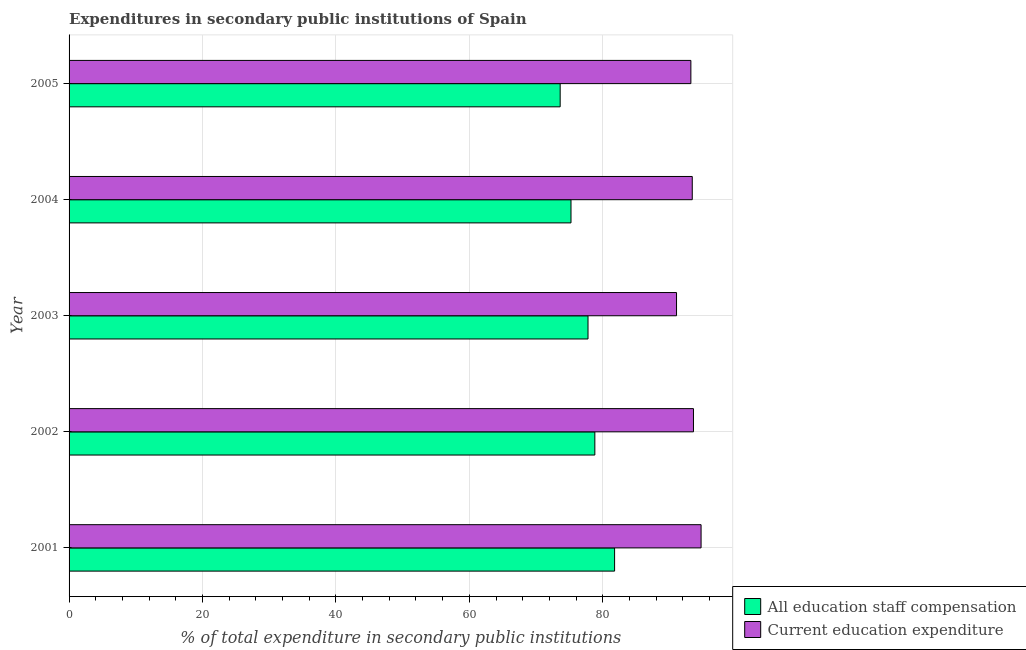Are the number of bars on each tick of the Y-axis equal?
Ensure brevity in your answer.  Yes. How many bars are there on the 3rd tick from the bottom?
Make the answer very short. 2. What is the expenditure in staff compensation in 2001?
Provide a succinct answer. 81.78. Across all years, what is the maximum expenditure in education?
Your answer should be compact. 94.74. Across all years, what is the minimum expenditure in education?
Provide a short and direct response. 91.06. In which year was the expenditure in staff compensation minimum?
Provide a short and direct response. 2005. What is the total expenditure in education in the graph?
Give a very brief answer. 466.05. What is the difference between the expenditure in staff compensation in 2001 and that in 2004?
Give a very brief answer. 6.53. What is the difference between the expenditure in education in 2005 and the expenditure in staff compensation in 2003?
Give a very brief answer. 15.42. What is the average expenditure in staff compensation per year?
Offer a very short reply. 77.45. In the year 2001, what is the difference between the expenditure in staff compensation and expenditure in education?
Your response must be concise. -12.97. In how many years, is the expenditure in staff compensation greater than 56 %?
Ensure brevity in your answer.  5. What is the ratio of the expenditure in staff compensation in 2001 to that in 2002?
Keep it short and to the point. 1.04. Is the difference between the expenditure in education in 2001 and 2005 greater than the difference between the expenditure in staff compensation in 2001 and 2005?
Provide a short and direct response. No. What is the difference between the highest and the second highest expenditure in education?
Offer a very short reply. 1.14. What is the difference between the highest and the lowest expenditure in education?
Your answer should be very brief. 3.68. Is the sum of the expenditure in education in 2002 and 2004 greater than the maximum expenditure in staff compensation across all years?
Keep it short and to the point. Yes. What does the 2nd bar from the top in 2001 represents?
Offer a very short reply. All education staff compensation. What does the 2nd bar from the bottom in 2002 represents?
Give a very brief answer. Current education expenditure. How many bars are there?
Offer a terse response. 10. Are all the bars in the graph horizontal?
Provide a succinct answer. Yes. How many years are there in the graph?
Ensure brevity in your answer.  5. Does the graph contain any zero values?
Offer a terse response. No. How many legend labels are there?
Ensure brevity in your answer.  2. How are the legend labels stacked?
Your answer should be very brief. Vertical. What is the title of the graph?
Your answer should be compact. Expenditures in secondary public institutions of Spain. What is the label or title of the X-axis?
Provide a short and direct response. % of total expenditure in secondary public institutions. What is the % of total expenditure in secondary public institutions in All education staff compensation in 2001?
Your answer should be compact. 81.78. What is the % of total expenditure in secondary public institutions in Current education expenditure in 2001?
Keep it short and to the point. 94.74. What is the % of total expenditure in secondary public institutions of All education staff compensation in 2002?
Offer a very short reply. 78.82. What is the % of total expenditure in secondary public institutions of Current education expenditure in 2002?
Your answer should be compact. 93.6. What is the % of total expenditure in secondary public institutions in All education staff compensation in 2003?
Keep it short and to the point. 77.79. What is the % of total expenditure in secondary public institutions in Current education expenditure in 2003?
Keep it short and to the point. 91.06. What is the % of total expenditure in secondary public institutions of All education staff compensation in 2004?
Offer a terse response. 75.24. What is the % of total expenditure in secondary public institutions in Current education expenditure in 2004?
Your answer should be compact. 93.42. What is the % of total expenditure in secondary public institutions of All education staff compensation in 2005?
Your response must be concise. 73.62. What is the % of total expenditure in secondary public institutions of Current education expenditure in 2005?
Offer a very short reply. 93.21. Across all years, what is the maximum % of total expenditure in secondary public institutions in All education staff compensation?
Your answer should be very brief. 81.78. Across all years, what is the maximum % of total expenditure in secondary public institutions in Current education expenditure?
Your answer should be compact. 94.74. Across all years, what is the minimum % of total expenditure in secondary public institutions of All education staff compensation?
Ensure brevity in your answer.  73.62. Across all years, what is the minimum % of total expenditure in secondary public institutions in Current education expenditure?
Offer a very short reply. 91.06. What is the total % of total expenditure in secondary public institutions in All education staff compensation in the graph?
Ensure brevity in your answer.  387.26. What is the total % of total expenditure in secondary public institutions in Current education expenditure in the graph?
Ensure brevity in your answer.  466.05. What is the difference between the % of total expenditure in secondary public institutions in All education staff compensation in 2001 and that in 2002?
Give a very brief answer. 2.96. What is the difference between the % of total expenditure in secondary public institutions in Current education expenditure in 2001 and that in 2002?
Give a very brief answer. 1.14. What is the difference between the % of total expenditure in secondary public institutions of All education staff compensation in 2001 and that in 2003?
Your answer should be compact. 3.98. What is the difference between the % of total expenditure in secondary public institutions of Current education expenditure in 2001 and that in 2003?
Provide a short and direct response. 3.68. What is the difference between the % of total expenditure in secondary public institutions of All education staff compensation in 2001 and that in 2004?
Provide a short and direct response. 6.53. What is the difference between the % of total expenditure in secondary public institutions of Current education expenditure in 2001 and that in 2004?
Provide a short and direct response. 1.32. What is the difference between the % of total expenditure in secondary public institutions in All education staff compensation in 2001 and that in 2005?
Give a very brief answer. 8.16. What is the difference between the % of total expenditure in secondary public institutions in Current education expenditure in 2001 and that in 2005?
Keep it short and to the point. 1.53. What is the difference between the % of total expenditure in secondary public institutions of All education staff compensation in 2002 and that in 2003?
Your answer should be compact. 1.02. What is the difference between the % of total expenditure in secondary public institutions of Current education expenditure in 2002 and that in 2003?
Offer a terse response. 2.54. What is the difference between the % of total expenditure in secondary public institutions of All education staff compensation in 2002 and that in 2004?
Offer a terse response. 3.57. What is the difference between the % of total expenditure in secondary public institutions of Current education expenditure in 2002 and that in 2004?
Ensure brevity in your answer.  0.18. What is the difference between the % of total expenditure in secondary public institutions in All education staff compensation in 2002 and that in 2005?
Ensure brevity in your answer.  5.2. What is the difference between the % of total expenditure in secondary public institutions of Current education expenditure in 2002 and that in 2005?
Provide a short and direct response. 0.39. What is the difference between the % of total expenditure in secondary public institutions of All education staff compensation in 2003 and that in 2004?
Offer a very short reply. 2.55. What is the difference between the % of total expenditure in secondary public institutions of Current education expenditure in 2003 and that in 2004?
Your answer should be very brief. -2.36. What is the difference between the % of total expenditure in secondary public institutions of All education staff compensation in 2003 and that in 2005?
Provide a short and direct response. 4.17. What is the difference between the % of total expenditure in secondary public institutions in Current education expenditure in 2003 and that in 2005?
Your answer should be very brief. -2.15. What is the difference between the % of total expenditure in secondary public institutions in All education staff compensation in 2004 and that in 2005?
Provide a short and direct response. 1.62. What is the difference between the % of total expenditure in secondary public institutions of Current education expenditure in 2004 and that in 2005?
Give a very brief answer. 0.21. What is the difference between the % of total expenditure in secondary public institutions in All education staff compensation in 2001 and the % of total expenditure in secondary public institutions in Current education expenditure in 2002?
Offer a terse response. -11.83. What is the difference between the % of total expenditure in secondary public institutions in All education staff compensation in 2001 and the % of total expenditure in secondary public institutions in Current education expenditure in 2003?
Your response must be concise. -9.29. What is the difference between the % of total expenditure in secondary public institutions in All education staff compensation in 2001 and the % of total expenditure in secondary public institutions in Current education expenditure in 2004?
Keep it short and to the point. -11.64. What is the difference between the % of total expenditure in secondary public institutions in All education staff compensation in 2001 and the % of total expenditure in secondary public institutions in Current education expenditure in 2005?
Your answer should be very brief. -11.44. What is the difference between the % of total expenditure in secondary public institutions in All education staff compensation in 2002 and the % of total expenditure in secondary public institutions in Current education expenditure in 2003?
Your answer should be compact. -12.25. What is the difference between the % of total expenditure in secondary public institutions of All education staff compensation in 2002 and the % of total expenditure in secondary public institutions of Current education expenditure in 2004?
Offer a very short reply. -14.6. What is the difference between the % of total expenditure in secondary public institutions in All education staff compensation in 2002 and the % of total expenditure in secondary public institutions in Current education expenditure in 2005?
Keep it short and to the point. -14.4. What is the difference between the % of total expenditure in secondary public institutions of All education staff compensation in 2003 and the % of total expenditure in secondary public institutions of Current education expenditure in 2004?
Give a very brief answer. -15.63. What is the difference between the % of total expenditure in secondary public institutions in All education staff compensation in 2003 and the % of total expenditure in secondary public institutions in Current education expenditure in 2005?
Keep it short and to the point. -15.42. What is the difference between the % of total expenditure in secondary public institutions of All education staff compensation in 2004 and the % of total expenditure in secondary public institutions of Current education expenditure in 2005?
Make the answer very short. -17.97. What is the average % of total expenditure in secondary public institutions in All education staff compensation per year?
Offer a terse response. 77.45. What is the average % of total expenditure in secondary public institutions of Current education expenditure per year?
Make the answer very short. 93.21. In the year 2001, what is the difference between the % of total expenditure in secondary public institutions in All education staff compensation and % of total expenditure in secondary public institutions in Current education expenditure?
Provide a short and direct response. -12.97. In the year 2002, what is the difference between the % of total expenditure in secondary public institutions in All education staff compensation and % of total expenditure in secondary public institutions in Current education expenditure?
Keep it short and to the point. -14.79. In the year 2003, what is the difference between the % of total expenditure in secondary public institutions of All education staff compensation and % of total expenditure in secondary public institutions of Current education expenditure?
Provide a succinct answer. -13.27. In the year 2004, what is the difference between the % of total expenditure in secondary public institutions of All education staff compensation and % of total expenditure in secondary public institutions of Current education expenditure?
Your response must be concise. -18.18. In the year 2005, what is the difference between the % of total expenditure in secondary public institutions in All education staff compensation and % of total expenditure in secondary public institutions in Current education expenditure?
Ensure brevity in your answer.  -19.59. What is the ratio of the % of total expenditure in secondary public institutions of All education staff compensation in 2001 to that in 2002?
Give a very brief answer. 1.04. What is the ratio of the % of total expenditure in secondary public institutions of Current education expenditure in 2001 to that in 2002?
Ensure brevity in your answer.  1.01. What is the ratio of the % of total expenditure in secondary public institutions in All education staff compensation in 2001 to that in 2003?
Your answer should be compact. 1.05. What is the ratio of the % of total expenditure in secondary public institutions in Current education expenditure in 2001 to that in 2003?
Provide a succinct answer. 1.04. What is the ratio of the % of total expenditure in secondary public institutions of All education staff compensation in 2001 to that in 2004?
Make the answer very short. 1.09. What is the ratio of the % of total expenditure in secondary public institutions in Current education expenditure in 2001 to that in 2004?
Keep it short and to the point. 1.01. What is the ratio of the % of total expenditure in secondary public institutions in All education staff compensation in 2001 to that in 2005?
Provide a succinct answer. 1.11. What is the ratio of the % of total expenditure in secondary public institutions in Current education expenditure in 2001 to that in 2005?
Your response must be concise. 1.02. What is the ratio of the % of total expenditure in secondary public institutions of All education staff compensation in 2002 to that in 2003?
Your response must be concise. 1.01. What is the ratio of the % of total expenditure in secondary public institutions in Current education expenditure in 2002 to that in 2003?
Your answer should be very brief. 1.03. What is the ratio of the % of total expenditure in secondary public institutions in All education staff compensation in 2002 to that in 2004?
Offer a terse response. 1.05. What is the ratio of the % of total expenditure in secondary public institutions in All education staff compensation in 2002 to that in 2005?
Your answer should be compact. 1.07. What is the ratio of the % of total expenditure in secondary public institutions in All education staff compensation in 2003 to that in 2004?
Offer a terse response. 1.03. What is the ratio of the % of total expenditure in secondary public institutions in Current education expenditure in 2003 to that in 2004?
Your answer should be very brief. 0.97. What is the ratio of the % of total expenditure in secondary public institutions in All education staff compensation in 2003 to that in 2005?
Keep it short and to the point. 1.06. What is the ratio of the % of total expenditure in secondary public institutions in Current education expenditure in 2003 to that in 2005?
Ensure brevity in your answer.  0.98. What is the ratio of the % of total expenditure in secondary public institutions in All education staff compensation in 2004 to that in 2005?
Ensure brevity in your answer.  1.02. What is the difference between the highest and the second highest % of total expenditure in secondary public institutions of All education staff compensation?
Provide a short and direct response. 2.96. What is the difference between the highest and the second highest % of total expenditure in secondary public institutions of Current education expenditure?
Your answer should be compact. 1.14. What is the difference between the highest and the lowest % of total expenditure in secondary public institutions of All education staff compensation?
Offer a very short reply. 8.16. What is the difference between the highest and the lowest % of total expenditure in secondary public institutions in Current education expenditure?
Your answer should be very brief. 3.68. 